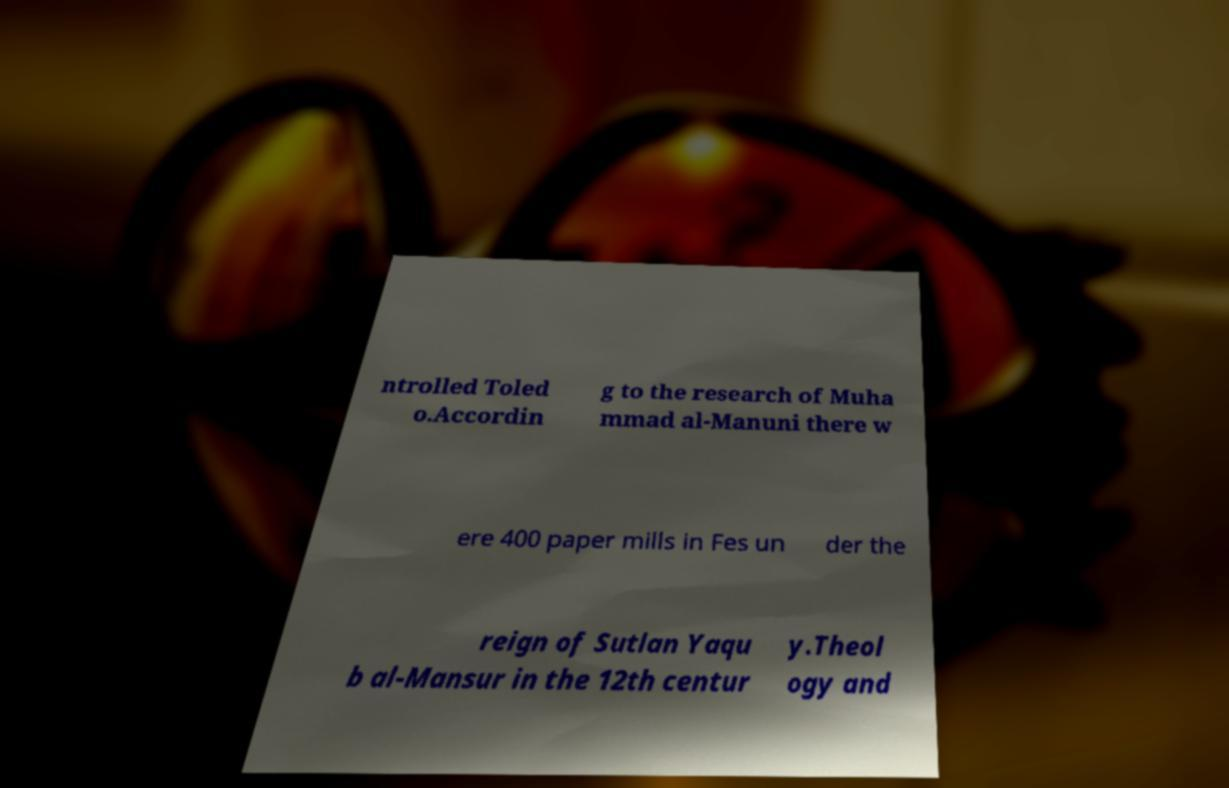What messages or text are displayed in this image? I need them in a readable, typed format. ntrolled Toled o.Accordin g to the research of Muha mmad al-Manuni there w ere 400 paper mills in Fes un der the reign of Sutlan Yaqu b al-Mansur in the 12th centur y.Theol ogy and 